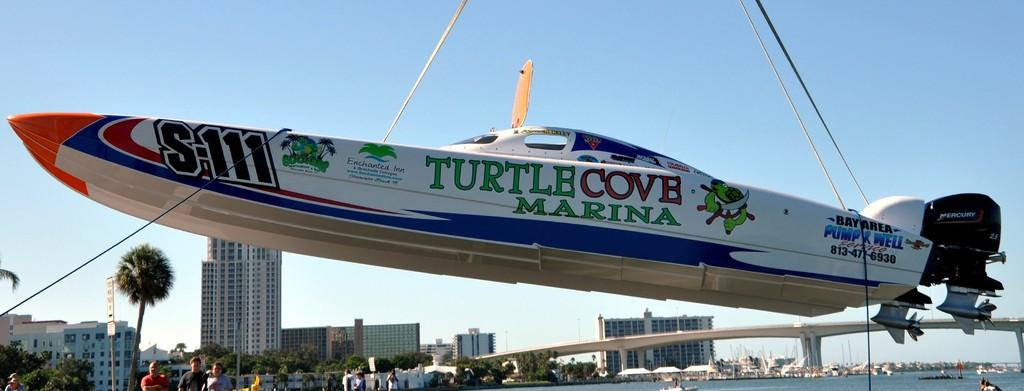<image>
Describe the image concisely. A speed boat is suspended in the air with the words Turtle Cove Marina painted on the side of it. 